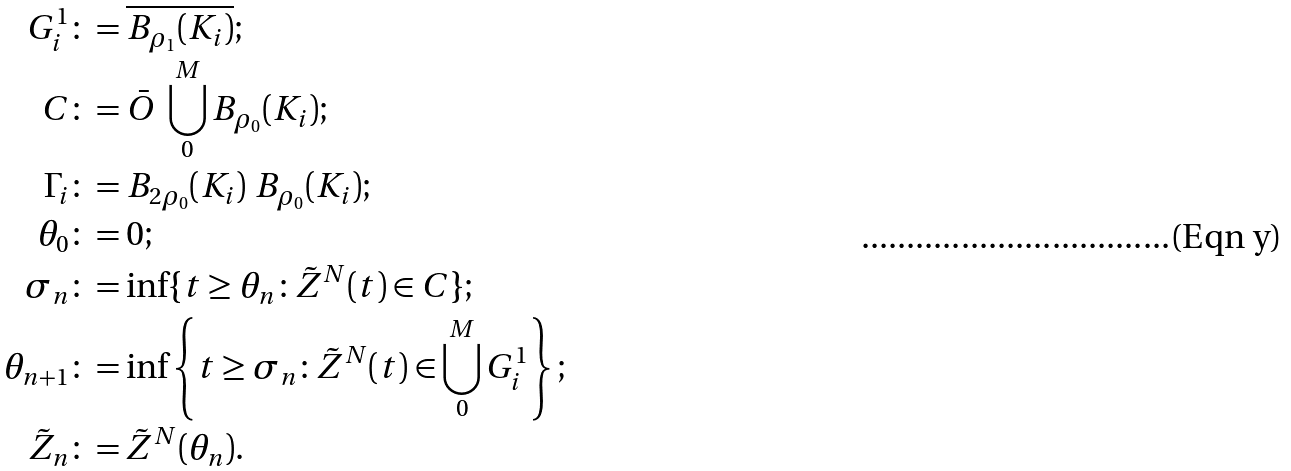Convert formula to latex. <formula><loc_0><loc_0><loc_500><loc_500>G ^ { 1 } _ { i } & \colon = \overline { B _ { \rho _ { 1 } } ( K _ { i } ) } ; \\ C & \colon = \bar { O } \ \bigcup _ { 0 } ^ { M } B _ { \rho _ { 0 } } ( K _ { i } ) ; \\ \Gamma _ { i } & \colon = B _ { 2 \rho _ { 0 } } ( K _ { i } ) \ B _ { \rho _ { 0 } } ( K _ { i } ) ; \\ \theta _ { 0 } & \colon = 0 ; \\ \sigma _ { n } & \colon = \inf \{ t \geq \theta _ { n } \colon \tilde { Z } ^ { N } ( t ) \in C \} ; \\ \theta _ { n + 1 } & \colon = \inf \left \{ t \geq \sigma _ { n } \colon \tilde { Z } ^ { N } ( t ) \in \bigcup _ { 0 } ^ { M } G ^ { 1 } _ { i } \right \} ; \\ \tilde { Z } _ { n } & \colon = \tilde { Z } ^ { N } ( \theta _ { n } ) .</formula> 